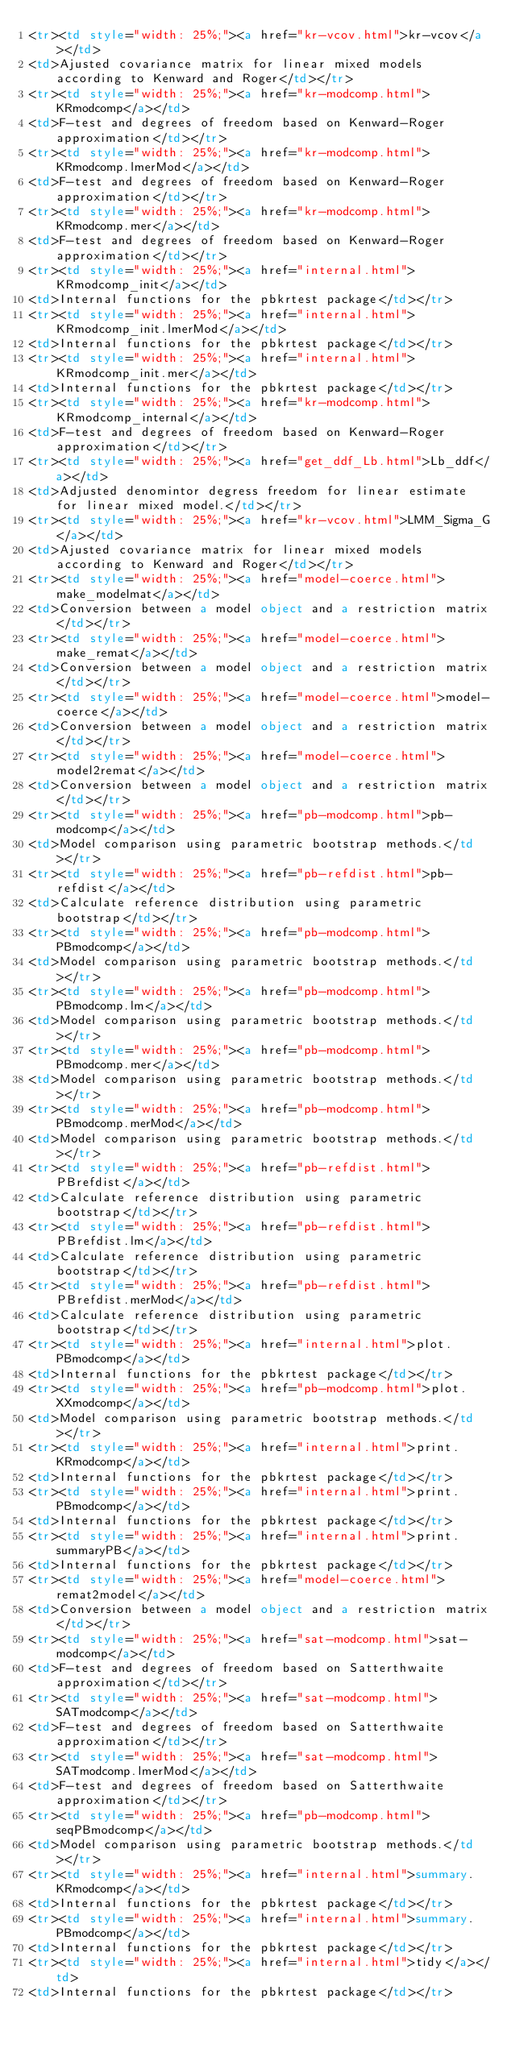<code> <loc_0><loc_0><loc_500><loc_500><_HTML_><tr><td style="width: 25%;"><a href="kr-vcov.html">kr-vcov</a></td>
<td>Ajusted covariance matrix for linear mixed models according to Kenward and Roger</td></tr>
<tr><td style="width: 25%;"><a href="kr-modcomp.html">KRmodcomp</a></td>
<td>F-test and degrees of freedom based on Kenward-Roger approximation</td></tr>
<tr><td style="width: 25%;"><a href="kr-modcomp.html">KRmodcomp.lmerMod</a></td>
<td>F-test and degrees of freedom based on Kenward-Roger approximation</td></tr>
<tr><td style="width: 25%;"><a href="kr-modcomp.html">KRmodcomp.mer</a></td>
<td>F-test and degrees of freedom based on Kenward-Roger approximation</td></tr>
<tr><td style="width: 25%;"><a href="internal.html">KRmodcomp_init</a></td>
<td>Internal functions for the pbkrtest package</td></tr>
<tr><td style="width: 25%;"><a href="internal.html">KRmodcomp_init.lmerMod</a></td>
<td>Internal functions for the pbkrtest package</td></tr>
<tr><td style="width: 25%;"><a href="internal.html">KRmodcomp_init.mer</a></td>
<td>Internal functions for the pbkrtest package</td></tr>
<tr><td style="width: 25%;"><a href="kr-modcomp.html">KRmodcomp_internal</a></td>
<td>F-test and degrees of freedom based on Kenward-Roger approximation</td></tr>
<tr><td style="width: 25%;"><a href="get_ddf_Lb.html">Lb_ddf</a></td>
<td>Adjusted denomintor degress freedom for linear estimate for linear mixed model.</td></tr>
<tr><td style="width: 25%;"><a href="kr-vcov.html">LMM_Sigma_G</a></td>
<td>Ajusted covariance matrix for linear mixed models according to Kenward and Roger</td></tr>
<tr><td style="width: 25%;"><a href="model-coerce.html">make_modelmat</a></td>
<td>Conversion between a model object and a restriction matrix</td></tr>
<tr><td style="width: 25%;"><a href="model-coerce.html">make_remat</a></td>
<td>Conversion between a model object and a restriction matrix</td></tr>
<tr><td style="width: 25%;"><a href="model-coerce.html">model-coerce</a></td>
<td>Conversion between a model object and a restriction matrix</td></tr>
<tr><td style="width: 25%;"><a href="model-coerce.html">model2remat</a></td>
<td>Conversion between a model object and a restriction matrix</td></tr>
<tr><td style="width: 25%;"><a href="pb-modcomp.html">pb-modcomp</a></td>
<td>Model comparison using parametric bootstrap methods.</td></tr>
<tr><td style="width: 25%;"><a href="pb-refdist.html">pb-refdist</a></td>
<td>Calculate reference distribution using parametric bootstrap</td></tr>
<tr><td style="width: 25%;"><a href="pb-modcomp.html">PBmodcomp</a></td>
<td>Model comparison using parametric bootstrap methods.</td></tr>
<tr><td style="width: 25%;"><a href="pb-modcomp.html">PBmodcomp.lm</a></td>
<td>Model comparison using parametric bootstrap methods.</td></tr>
<tr><td style="width: 25%;"><a href="pb-modcomp.html">PBmodcomp.mer</a></td>
<td>Model comparison using parametric bootstrap methods.</td></tr>
<tr><td style="width: 25%;"><a href="pb-modcomp.html">PBmodcomp.merMod</a></td>
<td>Model comparison using parametric bootstrap methods.</td></tr>
<tr><td style="width: 25%;"><a href="pb-refdist.html">PBrefdist</a></td>
<td>Calculate reference distribution using parametric bootstrap</td></tr>
<tr><td style="width: 25%;"><a href="pb-refdist.html">PBrefdist.lm</a></td>
<td>Calculate reference distribution using parametric bootstrap</td></tr>
<tr><td style="width: 25%;"><a href="pb-refdist.html">PBrefdist.merMod</a></td>
<td>Calculate reference distribution using parametric bootstrap</td></tr>
<tr><td style="width: 25%;"><a href="internal.html">plot.PBmodcomp</a></td>
<td>Internal functions for the pbkrtest package</td></tr>
<tr><td style="width: 25%;"><a href="pb-modcomp.html">plot.XXmodcomp</a></td>
<td>Model comparison using parametric bootstrap methods.</td></tr>
<tr><td style="width: 25%;"><a href="internal.html">print.KRmodcomp</a></td>
<td>Internal functions for the pbkrtest package</td></tr>
<tr><td style="width: 25%;"><a href="internal.html">print.PBmodcomp</a></td>
<td>Internal functions for the pbkrtest package</td></tr>
<tr><td style="width: 25%;"><a href="internal.html">print.summaryPB</a></td>
<td>Internal functions for the pbkrtest package</td></tr>
<tr><td style="width: 25%;"><a href="model-coerce.html">remat2model</a></td>
<td>Conversion between a model object and a restriction matrix</td></tr>
<tr><td style="width: 25%;"><a href="sat-modcomp.html">sat-modcomp</a></td>
<td>F-test and degrees of freedom based on Satterthwaite approximation</td></tr>
<tr><td style="width: 25%;"><a href="sat-modcomp.html">SATmodcomp</a></td>
<td>F-test and degrees of freedom based on Satterthwaite approximation</td></tr>
<tr><td style="width: 25%;"><a href="sat-modcomp.html">SATmodcomp.lmerMod</a></td>
<td>F-test and degrees of freedom based on Satterthwaite approximation</td></tr>
<tr><td style="width: 25%;"><a href="pb-modcomp.html">seqPBmodcomp</a></td>
<td>Model comparison using parametric bootstrap methods.</td></tr>
<tr><td style="width: 25%;"><a href="internal.html">summary.KRmodcomp</a></td>
<td>Internal functions for the pbkrtest package</td></tr>
<tr><td style="width: 25%;"><a href="internal.html">summary.PBmodcomp</a></td>
<td>Internal functions for the pbkrtest package</td></tr>
<tr><td style="width: 25%;"><a href="internal.html">tidy</a></td>
<td>Internal functions for the pbkrtest package</td></tr></code> 